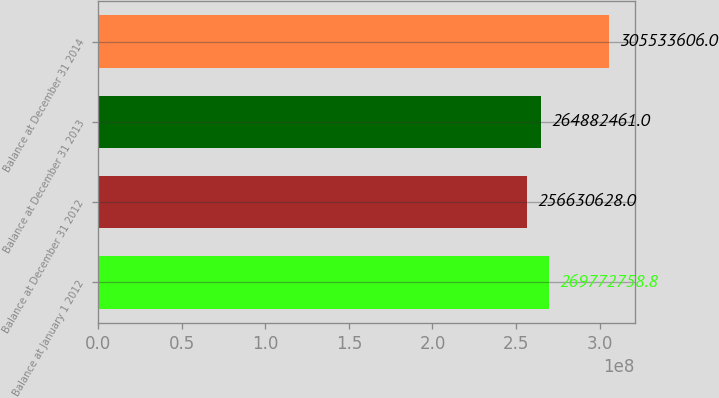<chart> <loc_0><loc_0><loc_500><loc_500><bar_chart><fcel>Balance at January 1 2012<fcel>Balance at December 31 2012<fcel>Balance at December 31 2013<fcel>Balance at December 31 2014<nl><fcel>2.69773e+08<fcel>2.56631e+08<fcel>2.64882e+08<fcel>3.05534e+08<nl></chart> 